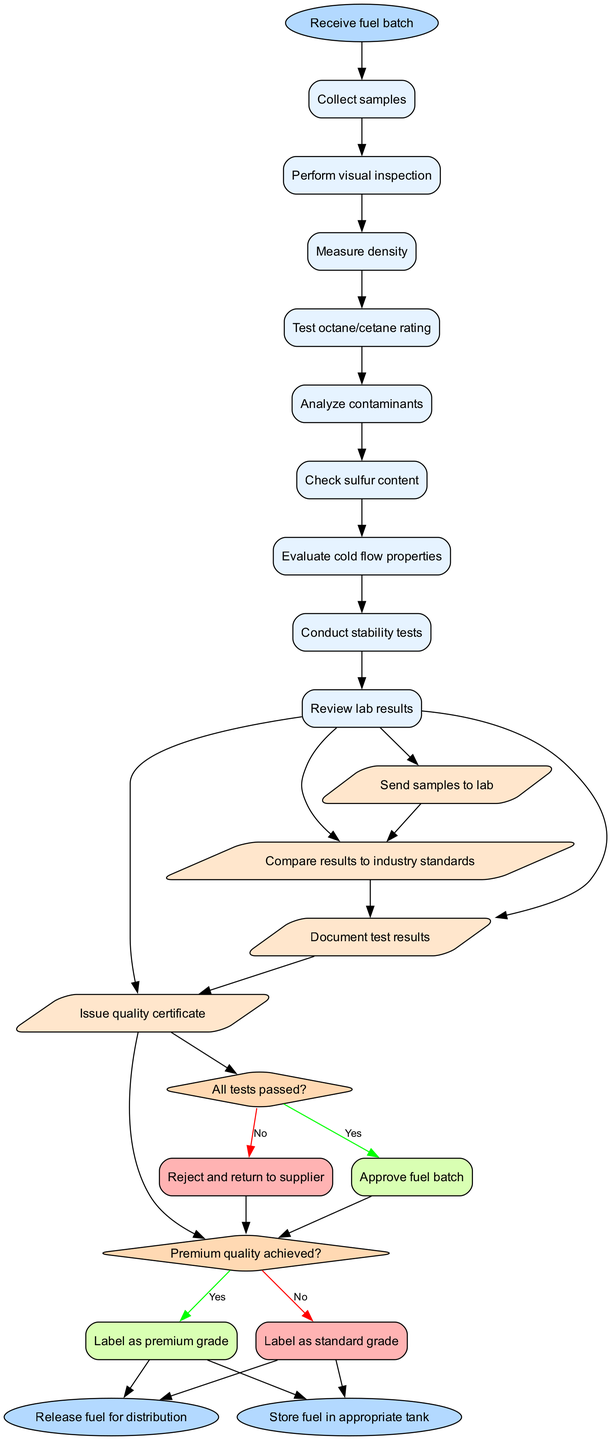What is the starting node of the diagram? The starting node of the diagram is "Receive fuel batch," which represents the initial step in the quality assurance process.
Answer: Receive fuel batch How many activities are listed in the diagram? The diagram lists a total of eight activities, which detail the steps taken in the fuel quality assurance process.
Answer: 8 What happens if all tests pass according to the diagram? If all tests pass, the diagram indicates that the next step is to "Approve fuel batch," meaning the fuel is deemed acceptable for further processing.
Answer: Approve fuel batch What is labeled if premium quality is achieved? If premium quality is achieved, the diagram indicates that the fuel will be "Label as premium grade," indicating its higher quality status.
Answer: Label as premium grade Which edge connects the last activity to the first decision? The edge connecting the last activity, "Conduct stability tests," to the first decision, "All tests passed?" is represented as "Document test results."
Answer: Document test results What happens when the fuel batch is rejected? If the answer to the "All tests passed?" decision is "No," the diagram shows that the fuel batch will be "Reject and return to supplier," meaning it will not proceed to distribution.
Answer: Reject and return to supplier How does the testing process conclude if a fuel batch is approved? After approving the fuel batch, it proceeds to the end node, where it is either "Release fuel for distribution" or "Store fuel in appropriate tank," indicating the final steps of processing.
Answer: Release fuel for distribution Which decision serves as the second major checkpoint in the process? The second major decision in the process is "Premium quality achieved?", which determines the classification of the fuel after the initial testing phase.
Answer: Premium quality achieved? 